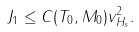Convert formula to latex. <formula><loc_0><loc_0><loc_500><loc_500>J _ { 1 } \leq C ( T _ { 0 } , M _ { 0 } ) \| v \| _ { H _ { s } } ^ { 2 } .</formula> 